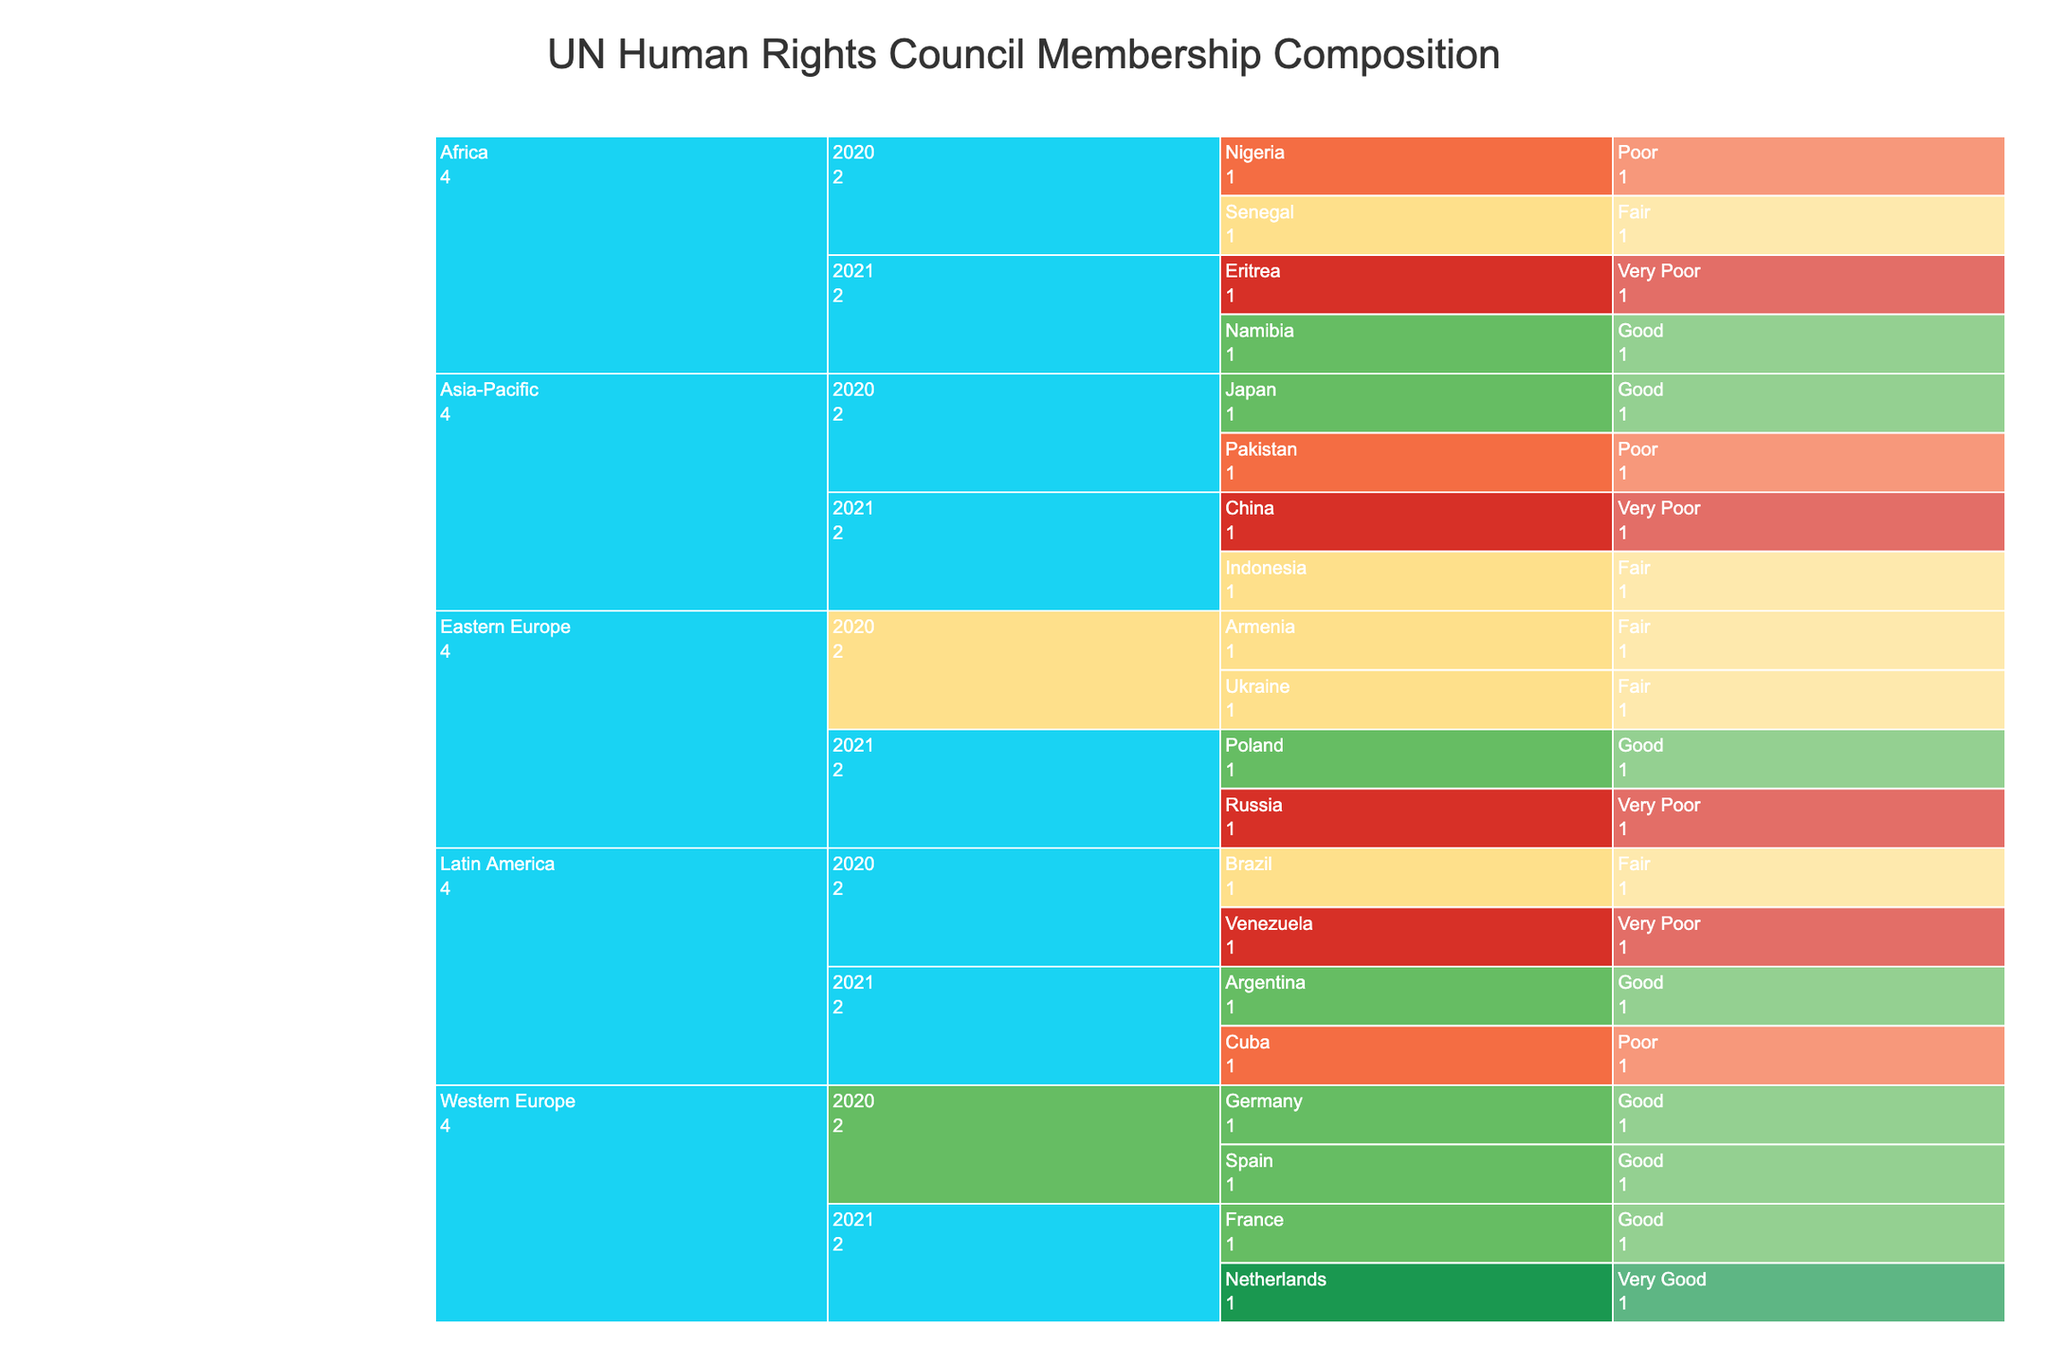How is the Human Rights Council Membership Composition distributed among the regions in 2020? To find the distribution for the year 2020, locate the branches under the "2020" nodes for each region. Africa includes Nigeria and Senegal, Asia-Pacific includes Japan and Pakistan, Eastern Europe includes Ukraine and Armenia, Latin America includes Brazil and Venezuela, and Western Europe includes Germany and Spain.
Answer: Africa: 2, Asia-Pacific: 2, Eastern Europe: 2, Latin America: 2, Western Europe: 2 Which region had the most countries with a "Very Poor" human rights record in 2021? To determine this, check which countries under the 2021 nodes in each region are marked with a "Very Poor" human rights record. Africa has Eritrea, Asia-Pacific has China, Eastern Europe has Russia, and Latin America has none. Count and compare the number of "Very Poor" records in each region.
Answer: Africa and Eastern Europe (1 each) What is the most common human rights record among the countries from Western Europe in both 2020 and 2021? To answer this, look at the human rights records for countries listed under Western Europe for both years. In 2020, both Germany and Spain have "Good" records. In 2021, France is "Good" and the Netherlands is "Very Good." Count and compare the frequency of each record.
Answer: Good Compare the representation of countries with "Good" human rights records across all regions in 2020 and 2021. Identify countries with "Good" records in 2020 and 2021 under each region. For 2020: Japan, Germany, Spain. For 2021: Namibia, Poland, Argentina, France. Then, count and compare these occurrences between the years.
Answer: 2020: 3, 2021: 4 In which year did Latin America have more countries with "Fair" human rights records? Locate the Latin America entries for 2020 and 2021. In 2020, Brazil is marked as "Fair." In 2021, no country in Latin America is marked as "Fair." Compare the counts.
Answer: 2020 Which region has countries with all levels of human rights records from "Very Poor" to "Very Good" in 2021? Look at the 2021 data for each region and check for the presence of countries with records labeled as "Very Poor," "Poor," "Fair," "Good," and "Very Good." Only Western Europe has both "Very Good" (Netherlands) and no "Poor" or "Very Poor" records. No region meets the full criteria.
Answer: None What is the total number of countries with "Poor" human rights records in Asia-Pacific over both years? Count the number of countries in Asia-Pacific with "Poor" human rights records for 2020 and 2021. In 2020, Pakistan has a "Poor" record. In 2021, there are none marked as "Poor." Sum them up.
Answer: 1 Which year had more members from Eastern Europe with "Fair" records? Check Eastern Europe for the years 2020 and 2021. In 2020, both Ukraine and Armenia are marked as "Fair." In 2021, no country is marked as "Fair." Compare the counts.
Answer: 2020 What is the proportion of countries with "Very Poor" human rights records among all regions in 2020 compared to 2021? Find the total number of countries with "Very Poor" records for 2020 and 2021. In 2020: Venezuela is "Very Poor." In 2021: Eritrea, China, Russia. Then, calculate the proportion by comparing the counts.
Answer: 2020: 1/12, 2021: 3/12 